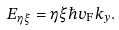<formula> <loc_0><loc_0><loc_500><loc_500>E _ { \eta \xi } = \eta \xi \hbar { v } _ { \text {F} } k _ { y } .</formula> 